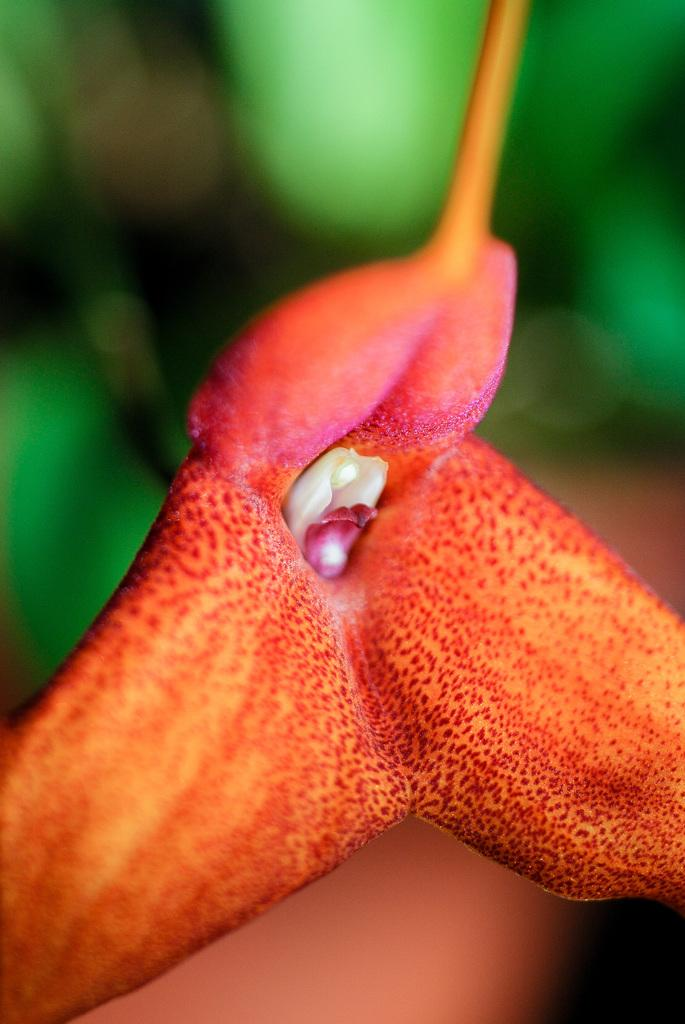What is the main subject of the image? There is a flower in the middle of the image. Can you describe the background of the image? The background of the image is blurry. What type of plot is being discussed in the image? There is no plot or discussion present in the image; it features a flower and a blurry background. Was the blurry background caused by an earthquake? There is no indication in the image that an earthquake occurred, and the blurry background is likely due to a different reason, such as the focus of the camera or the distance of the subject from the lens. 